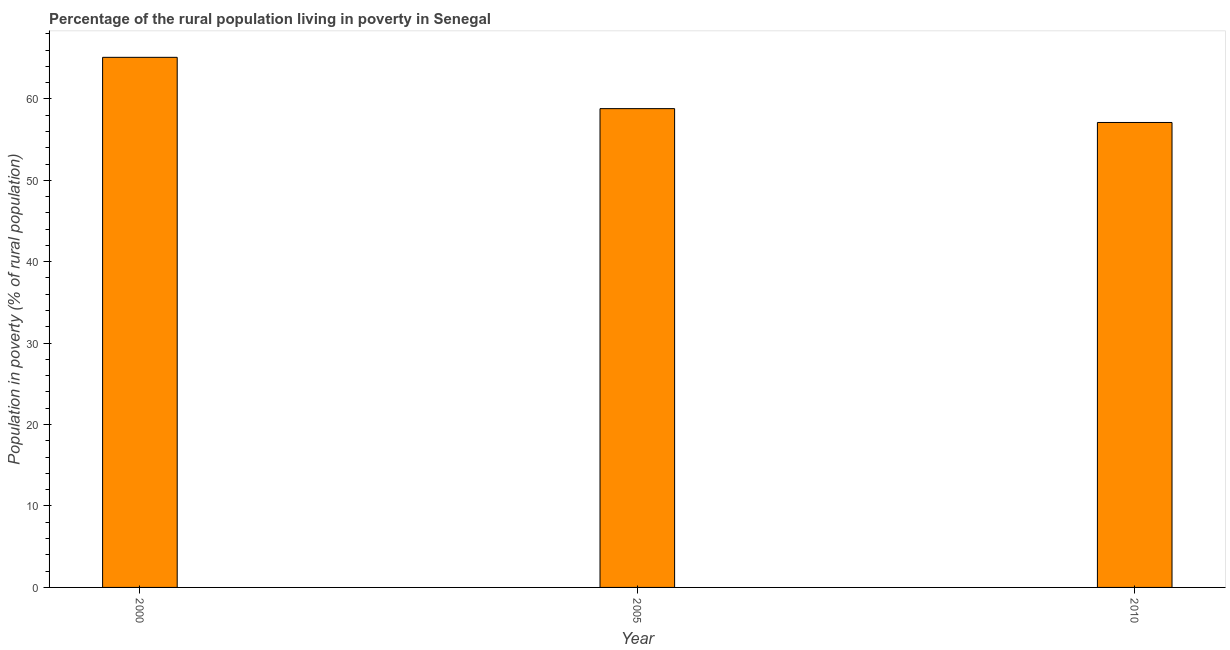Does the graph contain any zero values?
Give a very brief answer. No. What is the title of the graph?
Provide a succinct answer. Percentage of the rural population living in poverty in Senegal. What is the label or title of the X-axis?
Keep it short and to the point. Year. What is the label or title of the Y-axis?
Make the answer very short. Population in poverty (% of rural population). What is the percentage of rural population living below poverty line in 2010?
Your answer should be compact. 57.1. Across all years, what is the maximum percentage of rural population living below poverty line?
Offer a very short reply. 65.1. Across all years, what is the minimum percentage of rural population living below poverty line?
Provide a short and direct response. 57.1. In which year was the percentage of rural population living below poverty line minimum?
Provide a succinct answer. 2010. What is the sum of the percentage of rural population living below poverty line?
Make the answer very short. 181. What is the difference between the percentage of rural population living below poverty line in 2000 and 2005?
Give a very brief answer. 6.3. What is the average percentage of rural population living below poverty line per year?
Offer a very short reply. 60.33. What is the median percentage of rural population living below poverty line?
Your response must be concise. 58.8. In how many years, is the percentage of rural population living below poverty line greater than 4 %?
Give a very brief answer. 3. What is the ratio of the percentage of rural population living below poverty line in 2000 to that in 2010?
Provide a short and direct response. 1.14. Is the percentage of rural population living below poverty line in 2005 less than that in 2010?
Provide a succinct answer. No. What is the difference between the highest and the second highest percentage of rural population living below poverty line?
Offer a very short reply. 6.3. Is the sum of the percentage of rural population living below poverty line in 2005 and 2010 greater than the maximum percentage of rural population living below poverty line across all years?
Provide a short and direct response. Yes. What is the difference between the highest and the lowest percentage of rural population living below poverty line?
Make the answer very short. 8. How many bars are there?
Give a very brief answer. 3. What is the difference between two consecutive major ticks on the Y-axis?
Provide a short and direct response. 10. Are the values on the major ticks of Y-axis written in scientific E-notation?
Keep it short and to the point. No. What is the Population in poverty (% of rural population) of 2000?
Your response must be concise. 65.1. What is the Population in poverty (% of rural population) in 2005?
Keep it short and to the point. 58.8. What is the Population in poverty (% of rural population) in 2010?
Your answer should be very brief. 57.1. What is the difference between the Population in poverty (% of rural population) in 2000 and 2005?
Provide a succinct answer. 6.3. What is the ratio of the Population in poverty (% of rural population) in 2000 to that in 2005?
Keep it short and to the point. 1.11. What is the ratio of the Population in poverty (% of rural population) in 2000 to that in 2010?
Give a very brief answer. 1.14. 